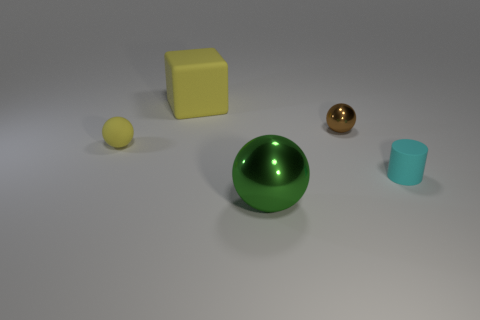Subtract all tiny spheres. How many spheres are left? 1 Add 3 large cyan shiny objects. How many objects exist? 8 Subtract all cylinders. How many objects are left? 4 Add 3 yellow metal balls. How many yellow metal balls exist? 3 Subtract 0 brown cubes. How many objects are left? 5 Subtract all rubber cubes. Subtract all cubes. How many objects are left? 3 Add 1 tiny yellow objects. How many tiny yellow objects are left? 2 